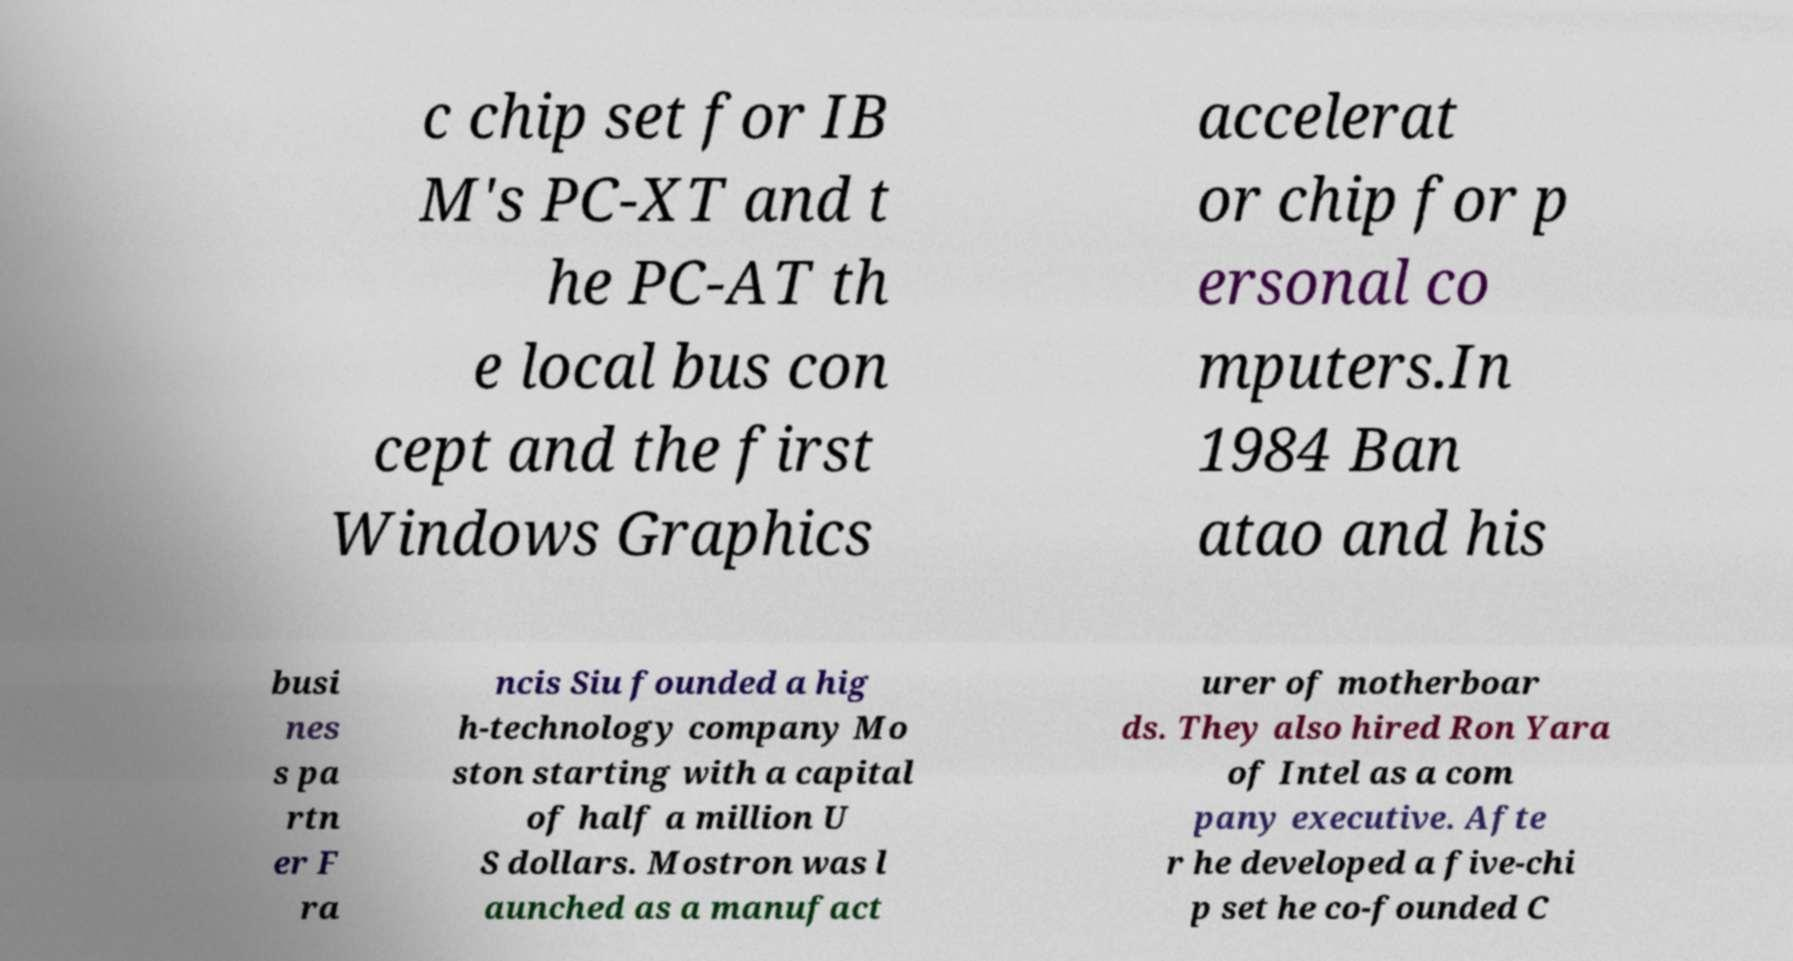Please identify and transcribe the text found in this image. c chip set for IB M's PC-XT and t he PC-AT th e local bus con cept and the first Windows Graphics accelerat or chip for p ersonal co mputers.In 1984 Ban atao and his busi nes s pa rtn er F ra ncis Siu founded a hig h-technology company Mo ston starting with a capital of half a million U S dollars. Mostron was l aunched as a manufact urer of motherboar ds. They also hired Ron Yara of Intel as a com pany executive. Afte r he developed a five-chi p set he co-founded C 